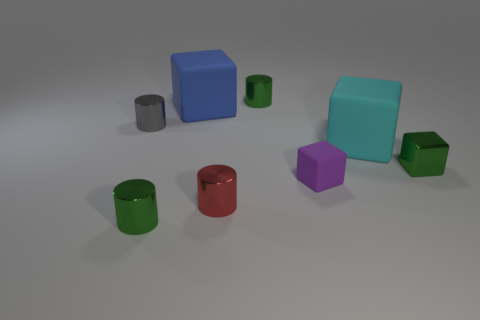There is a gray thing that is left of the purple object; what material is it?
Offer a terse response. Metal. How many objects are small metallic cubes in front of the big blue matte cube or balls?
Keep it short and to the point. 1. How many other objects are the same shape as the blue object?
Your answer should be compact. 3. There is a green thing left of the small red metal object; is its shape the same as the small purple matte object?
Offer a terse response. No. There is a metal cube; are there any big cyan objects right of it?
Offer a terse response. No. How many tiny things are either green metallic blocks or brown cylinders?
Give a very brief answer. 1. Does the purple object have the same material as the red thing?
Your answer should be compact. No. Is there a small cylinder that has the same color as the tiny matte object?
Offer a very short reply. No. What size is the red cylinder that is the same material as the gray cylinder?
Keep it short and to the point. Small. What is the shape of the shiny object that is right of the tiny green object that is behind the tiny metallic object that is right of the tiny purple matte block?
Your response must be concise. Cube. 